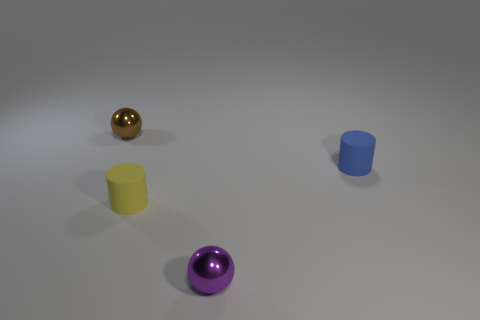Is there a tiny blue metallic thing of the same shape as the brown thing?
Offer a terse response. No. What number of small cylinders are there?
Keep it short and to the point. 2. Are the tiny object that is in front of the tiny yellow thing and the tiny yellow cylinder made of the same material?
Ensure brevity in your answer.  No. Are there any green things of the same size as the blue object?
Your response must be concise. No. There is a small brown metal thing; does it have the same shape as the small metallic object on the right side of the yellow matte cylinder?
Offer a terse response. Yes. There is a rubber cylinder that is left of the metallic object that is on the right side of the small yellow cylinder; are there any tiny objects that are behind it?
Offer a terse response. Yes. What is the size of the yellow matte cylinder?
Make the answer very short. Small. There is a brown thing that is behind the small blue object; is it the same shape as the tiny purple shiny object?
Provide a short and direct response. Yes. There is another object that is the same shape as the brown metallic thing; what color is it?
Offer a very short reply. Purple. Is there any other thing that is the same material as the small blue cylinder?
Provide a succinct answer. Yes. 